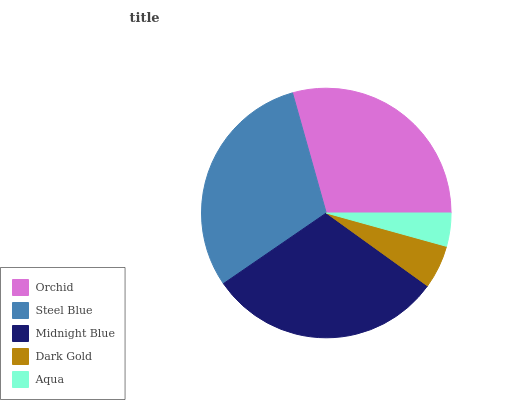Is Aqua the minimum?
Answer yes or no. Yes. Is Midnight Blue the maximum?
Answer yes or no. Yes. Is Steel Blue the minimum?
Answer yes or no. No. Is Steel Blue the maximum?
Answer yes or no. No. Is Steel Blue greater than Orchid?
Answer yes or no. Yes. Is Orchid less than Steel Blue?
Answer yes or no. Yes. Is Orchid greater than Steel Blue?
Answer yes or no. No. Is Steel Blue less than Orchid?
Answer yes or no. No. Is Orchid the high median?
Answer yes or no. Yes. Is Orchid the low median?
Answer yes or no. Yes. Is Aqua the high median?
Answer yes or no. No. Is Aqua the low median?
Answer yes or no. No. 